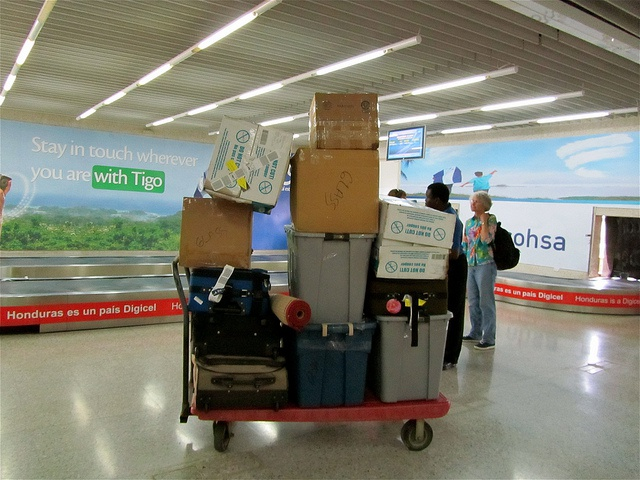Describe the objects in this image and their specific colors. I can see suitcase in darkgray, black, and gray tones, people in darkgray, gray, teal, and black tones, suitcase in darkgray, black, gray, darkgreen, and tan tones, suitcase in darkgray, black, brown, gray, and olive tones, and suitcase in darkgray, black, gray, and navy tones in this image. 